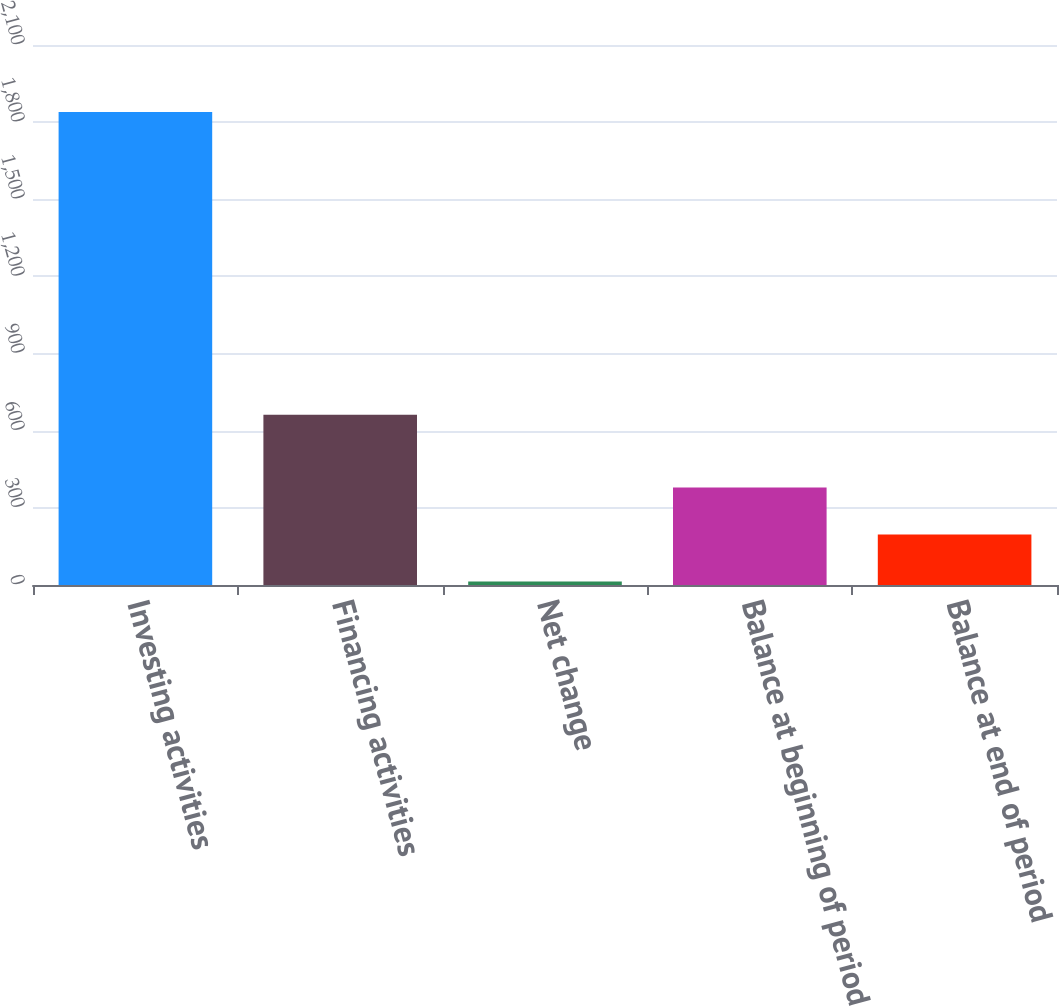<chart> <loc_0><loc_0><loc_500><loc_500><bar_chart><fcel>Investing activities<fcel>Financing activities<fcel>Net change<fcel>Balance at beginning of period<fcel>Balance at end of period<nl><fcel>1839<fcel>662<fcel>14<fcel>379<fcel>196.5<nl></chart> 